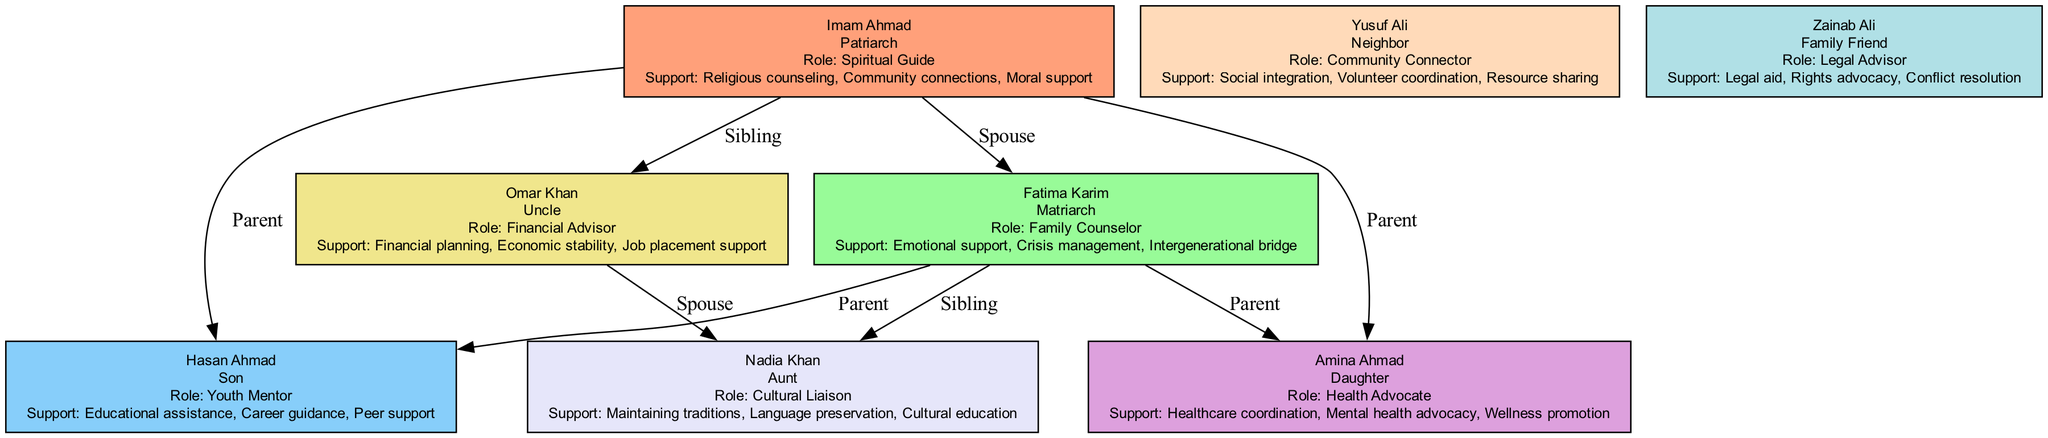What is the relationship of Hasan Ahmad to Imam Ahmad? The diagram shows that Hasan Ahmad is connected to Imam Ahmad with an edge labeled "Parent," indicating that Hasan Ahmad is the son of Imam Ahmad. This relationship can be found directly from the diagram.
Answer: Son How many support functions does Fatima Karim provide? Looking at the node for Fatima Karim, we can count the number of support functions listed, which are "Emotional support," "Crisis management," and "Intergenerational bridge." This totals to three functions, which is explicitly stated in the diagram.
Answer: Three Who is the cultural liaison in this family unit? By examining the nodes in the diagram, we can identify that Nadia Khan holds the role of "Cultural Liaison" as explicitly stated in her node description. This information is directly available without any additional reasoning.
Answer: Nadia Khan What is the primary role of Amina Ahmad? Amina Ahmad's role is identified in her node, where it states she serves as the "Health Advocate." This title reflects her primary responsibilities within the support network.
Answer: Health Advocate How many members are connected to Imam Ahmad? The diagram provides a visual indication that Imam Ahmad is connected to four family members through various relationships: Fatima Karim (spouse), Hasan Ahmad (son), Amina Ahmad (daughter), and Omar Khan (sibling). Counting these, we find they total to four connected members.
Answer: Four Which member provides healthcare coordination? Referring to the information in the diagram, we can find that Amina Ahmad is designated as the "Health Advocate" and her support functions specifically include "Healthcare coordination." This clearly indicates her primary contribution.
Answer: Amina Ahmad What support function does Omar Khan offer? By reviewing the node for Omar Khan, we see that his support functions include "Financial planning," "Economic stability," and "Job placement support." This shows the breadth of support offered within the family unit.
Answer: Financial planning Who is the neighbor in this family tree? Within the diagram, Yusuf Ali is labeled as the "Neighbor," demonstrating his role in the support network alongside the family members, which is explicitly shown in his node.
Answer: Yusuf Ali What is the relationship between Fatima Karim and Nadia Khan? The diagram shows both Fatima Karim and Nadia Khan are connected to Imam Ahmad and are labeled as "siblings," indicating their familial relationship through their respective connections to the patriarch.
Answer: Siblings 